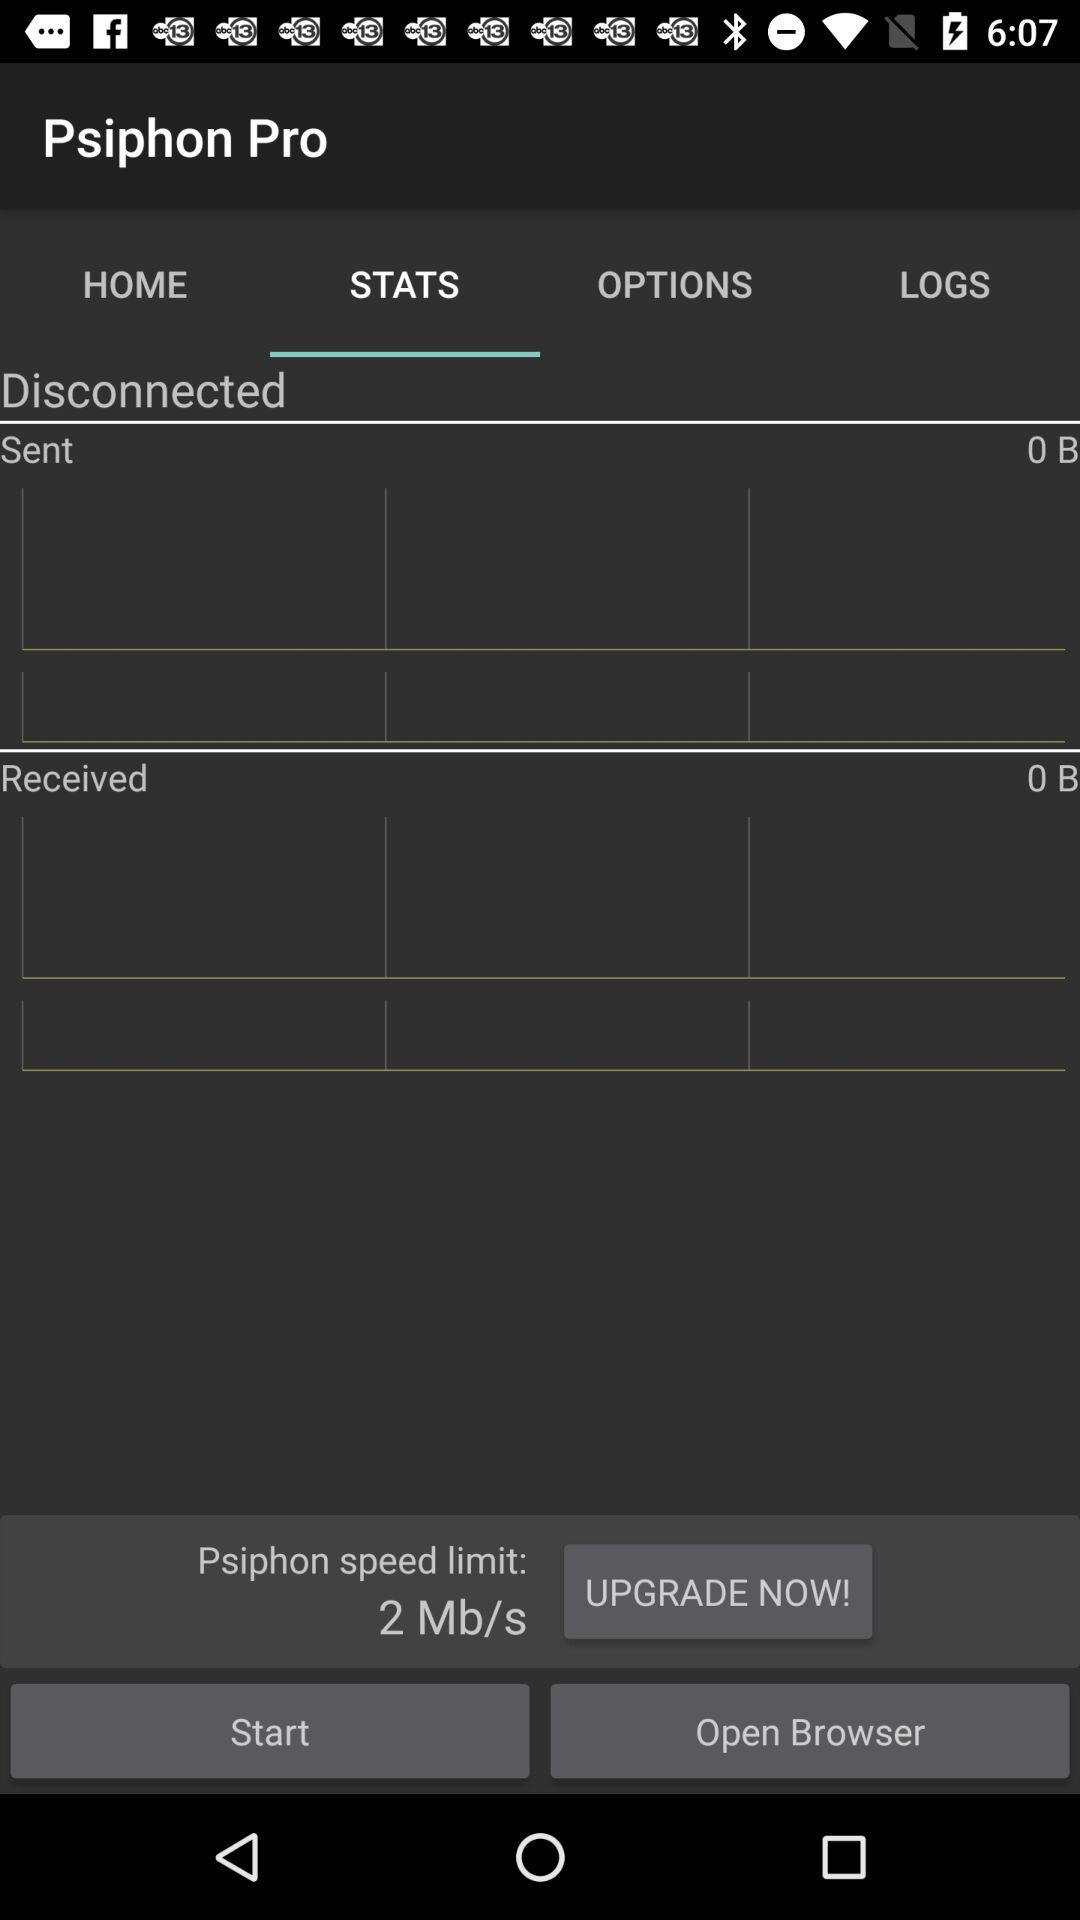Which is the selected tab? The selected tab is " STATS". 